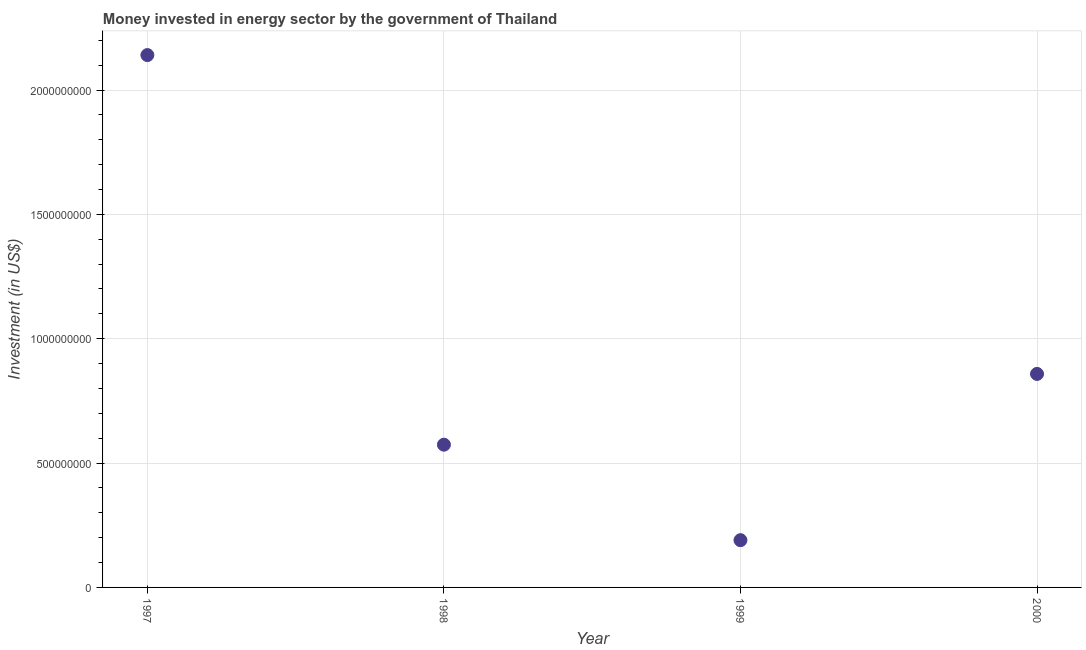What is the investment in energy in 1999?
Give a very brief answer. 1.90e+08. Across all years, what is the maximum investment in energy?
Keep it short and to the point. 2.14e+09. Across all years, what is the minimum investment in energy?
Your answer should be compact. 1.90e+08. In which year was the investment in energy maximum?
Ensure brevity in your answer.  1997. In which year was the investment in energy minimum?
Ensure brevity in your answer.  1999. What is the sum of the investment in energy?
Keep it short and to the point. 3.76e+09. What is the difference between the investment in energy in 1997 and 1998?
Ensure brevity in your answer.  1.57e+09. What is the average investment in energy per year?
Ensure brevity in your answer.  9.41e+08. What is the median investment in energy?
Keep it short and to the point. 7.16e+08. Do a majority of the years between 1997 and 1999 (inclusive) have investment in energy greater than 600000000 US$?
Provide a succinct answer. No. What is the ratio of the investment in energy in 1998 to that in 2000?
Provide a short and direct response. 0.67. Is the investment in energy in 1998 less than that in 1999?
Your response must be concise. No. What is the difference between the highest and the second highest investment in energy?
Offer a very short reply. 1.28e+09. Is the sum of the investment in energy in 1998 and 2000 greater than the maximum investment in energy across all years?
Keep it short and to the point. No. What is the difference between the highest and the lowest investment in energy?
Provide a succinct answer. 1.95e+09. Does the investment in energy monotonically increase over the years?
Ensure brevity in your answer.  No. How many years are there in the graph?
Offer a terse response. 4. Does the graph contain grids?
Offer a very short reply. Yes. What is the title of the graph?
Provide a succinct answer. Money invested in energy sector by the government of Thailand. What is the label or title of the X-axis?
Offer a terse response. Year. What is the label or title of the Y-axis?
Ensure brevity in your answer.  Investment (in US$). What is the Investment (in US$) in 1997?
Your answer should be very brief. 2.14e+09. What is the Investment (in US$) in 1998?
Your answer should be very brief. 5.74e+08. What is the Investment (in US$) in 1999?
Your answer should be very brief. 1.90e+08. What is the Investment (in US$) in 2000?
Your answer should be compact. 8.58e+08. What is the difference between the Investment (in US$) in 1997 and 1998?
Provide a short and direct response. 1.57e+09. What is the difference between the Investment (in US$) in 1997 and 1999?
Provide a succinct answer. 1.95e+09. What is the difference between the Investment (in US$) in 1997 and 2000?
Offer a terse response. 1.28e+09. What is the difference between the Investment (in US$) in 1998 and 1999?
Your response must be concise. 3.84e+08. What is the difference between the Investment (in US$) in 1998 and 2000?
Your answer should be compact. -2.84e+08. What is the difference between the Investment (in US$) in 1999 and 2000?
Give a very brief answer. -6.68e+08. What is the ratio of the Investment (in US$) in 1997 to that in 1998?
Your answer should be compact. 3.73. What is the ratio of the Investment (in US$) in 1997 to that in 1999?
Offer a very short reply. 11.27. What is the ratio of the Investment (in US$) in 1997 to that in 2000?
Make the answer very short. 2.49. What is the ratio of the Investment (in US$) in 1998 to that in 1999?
Provide a succinct answer. 3.02. What is the ratio of the Investment (in US$) in 1998 to that in 2000?
Make the answer very short. 0.67. What is the ratio of the Investment (in US$) in 1999 to that in 2000?
Ensure brevity in your answer.  0.22. 